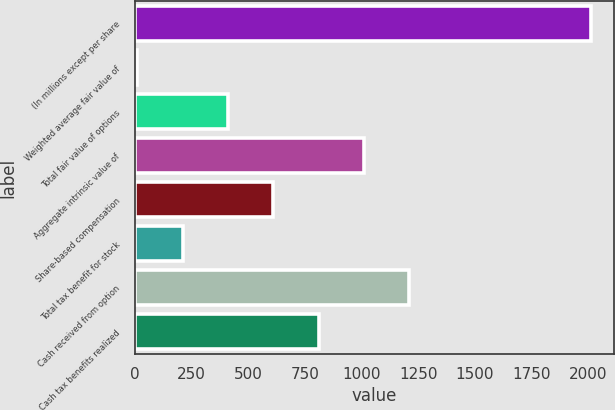Convert chart to OTSL. <chart><loc_0><loc_0><loc_500><loc_500><bar_chart><fcel>(In millions except per share<fcel>Weighted average fair value of<fcel>Total fair value of options<fcel>Aggregate intrinsic value of<fcel>Share-based compensation<fcel>Total tax benefit for stock<fcel>Cash received from option<fcel>Cash tax benefits realized<nl><fcel>2011<fcel>10.44<fcel>410.56<fcel>1010.74<fcel>610.62<fcel>210.5<fcel>1210.8<fcel>810.68<nl></chart> 